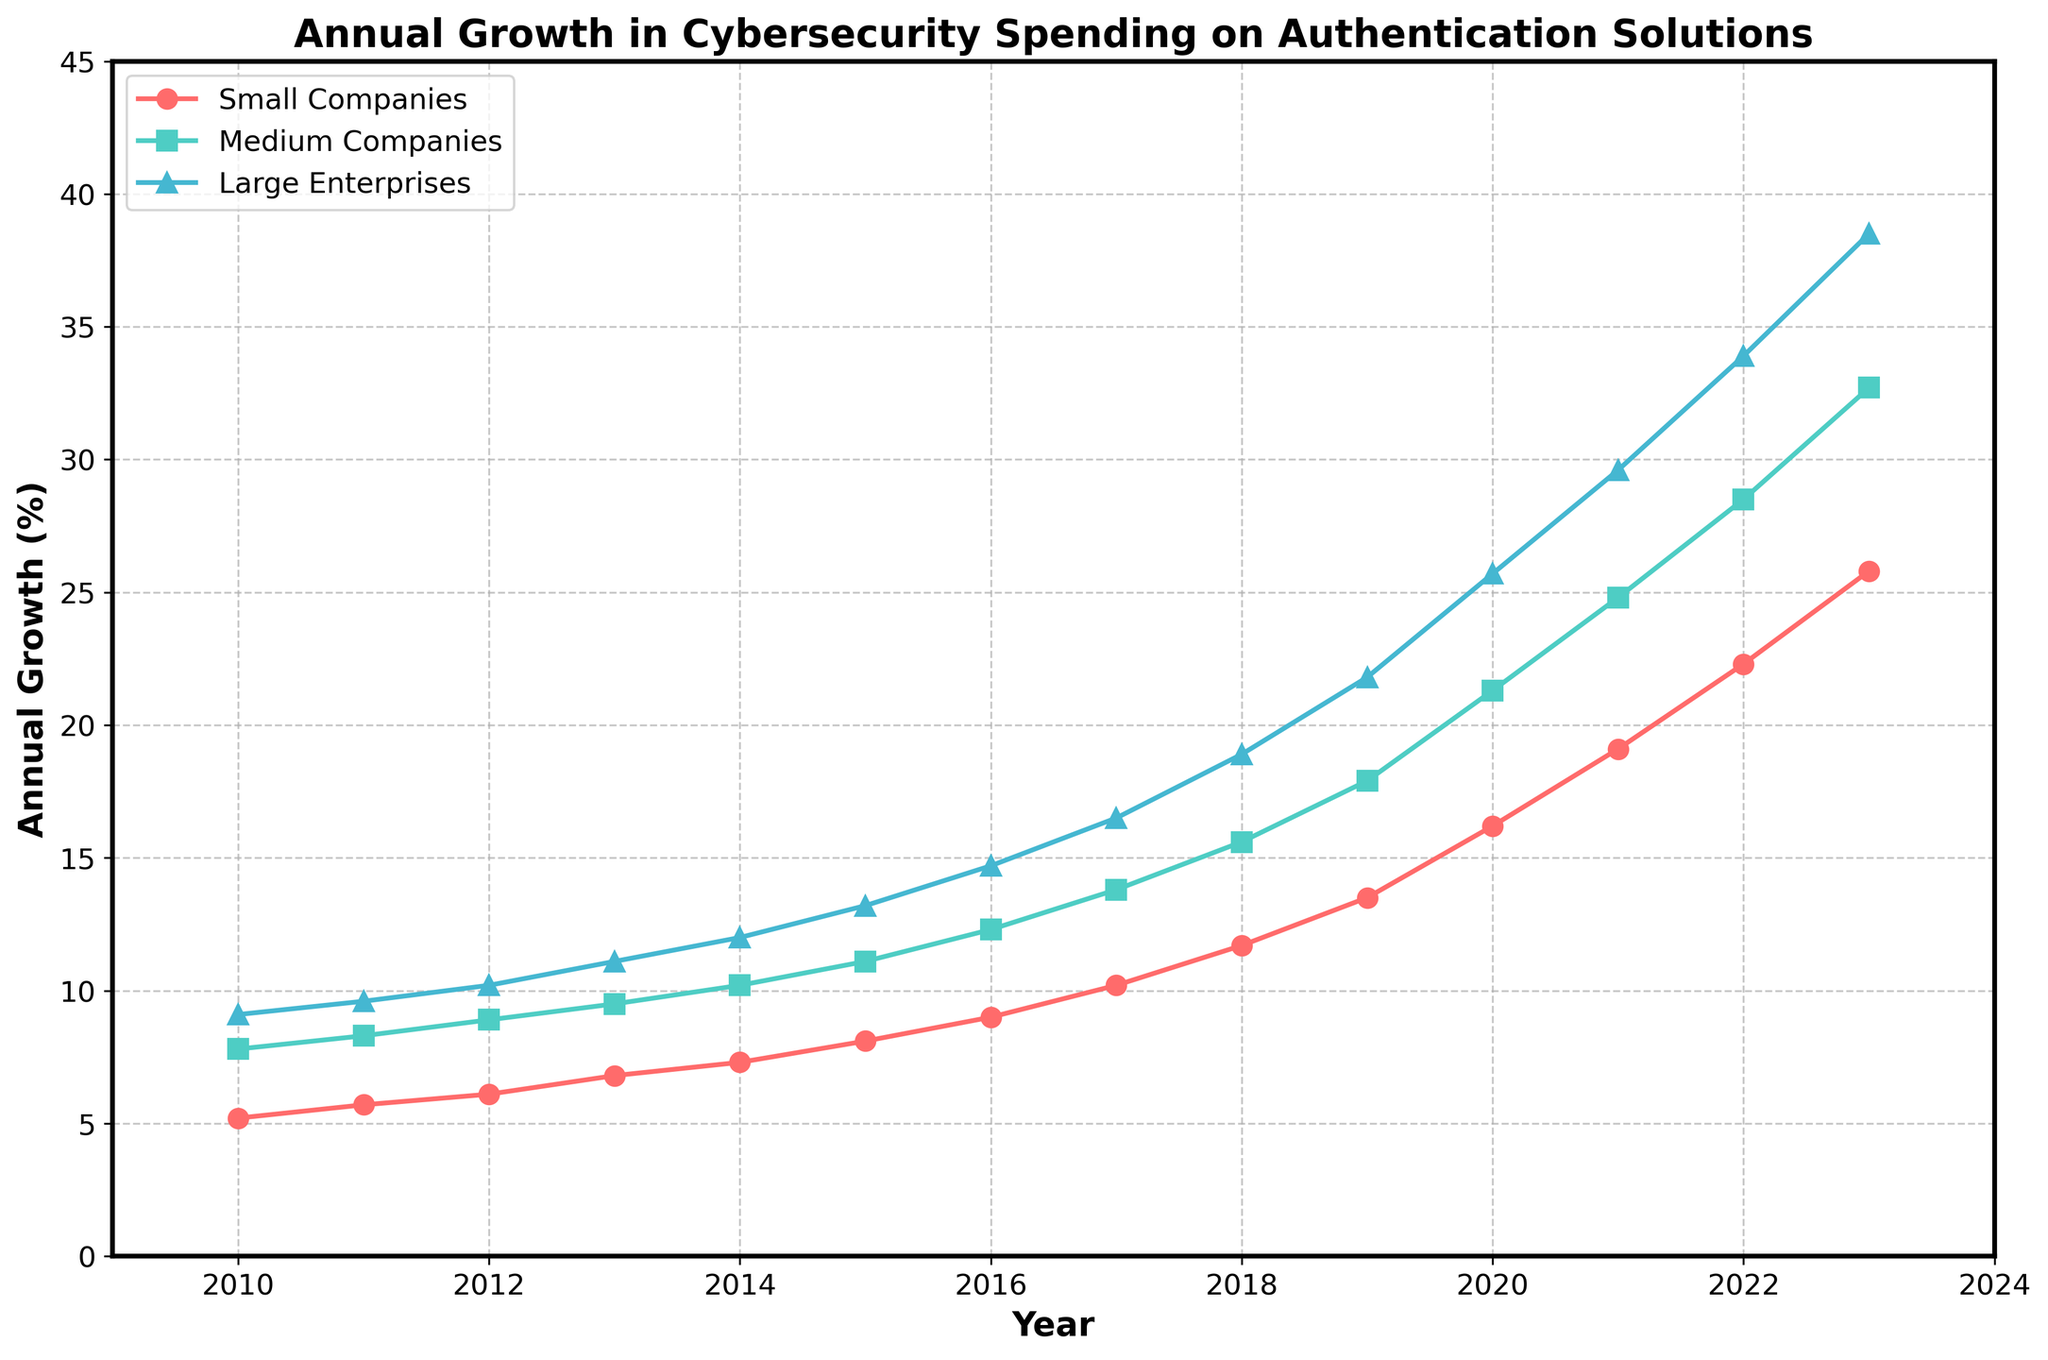What year saw the highest annual growth in cybersecurity spending for large enterprises? To determine the highest annual growth year for large enterprises, observe the blue line marked with triangles. The peak occurs in 2023 where the value is 38.5.
Answer: 2023 Which company size had the smallest growth percentage in 2015? Check the values for 2015 across all company sizes and compare them. Small companies had 8.1%, medium companies had 11.1%, and large enterprises had 13.2%. The smallest value is for small companies.
Answer: Small companies How much did the annual growth in cybersecurity spending for medium companies increase from 2010 to 2020? Find the values for medium companies in 2010 and 2020 from the turquoise line: 2010 is 7.8% and 2020 is 21.3%. The increase is 21.3 - 7.8 = 13.5%.
Answer: 13.5% Between which consecutive years did small companies experience the highest increase in annual growth percentage? Look at the increases year by year for the red line (small companies). The biggest jump is from 2019 (13.5%) to 2020 (16.2%), showing an increase of 16.2 - 13.5 = 2.7%.
Answer: 2019 to 2020 In 2021, which two company sizes had the closest annual growth percentages, and what were those values? For 2021, find the values: small companies had 19.1%, medium companies had 24.8%, large enterprises had 29.6%. The closest values are 24.8% and 29.6%. The difference is 29.6 - 24.8 = 4.8%.
Answer: Medium companies and large enterprises, 24.8% and 29.6% What was the total annual growth percentage in 2013 summed across all company sizes? Identify the 2013 values: small companies (6.8%), medium companies (9.5%), large enterprises (11.1%). The total is 6.8 + 9.5 + 11.1 = 27.4%.
Answer: 27.4% Between 2010 and 2023, which company size had the highest average annual growth? Calculate the average for each company size over the years:
Small companies: (5.2 + 5.7 + 6.1 + 6.8 + 7.3 + 8.1 + 9.0 + 10.2 + 11.7 + 13.5 + 16.2 + 19.1 + 22.3 + 25.8) / 14 = 11.9%.
Medium companies: (7.8 + 8.3 + 8.9 + 9.5 + 10.2 + 11.1 + 12.3 + 13.8 + 15.6 + 17.9 + 21.3 + 24.8 + 28.5 + 32.7) / 14 = 17.2%.
Large enterprises: (9.1 + 9.6 + 10.2 + 11.1 + 12.0 + 13.2 + 14.7 + 16.5 + 18.9 + 21.8 + 25.7 + 29.6 + 33.9 + 38.5) / 14 = 19.4%.
Answer: Large enterprises By what percentage did cybersecurity spending for medium companies grow from its initial to final value in the dataset? Initial value for medium companies in 2010 is 7.8%, and the final value in 2023 is 32.7%. The growth is ((32.7 - 7.8) / 7.8) * 100% = 319.2%.
Answer: 319.2% Which company size consistently showed the highest annual growth across all years? Observe the three lines and see which one is consistently the highest across all years. The blue line (large enterprises) is always the highest.
Answer: Large enterprises 